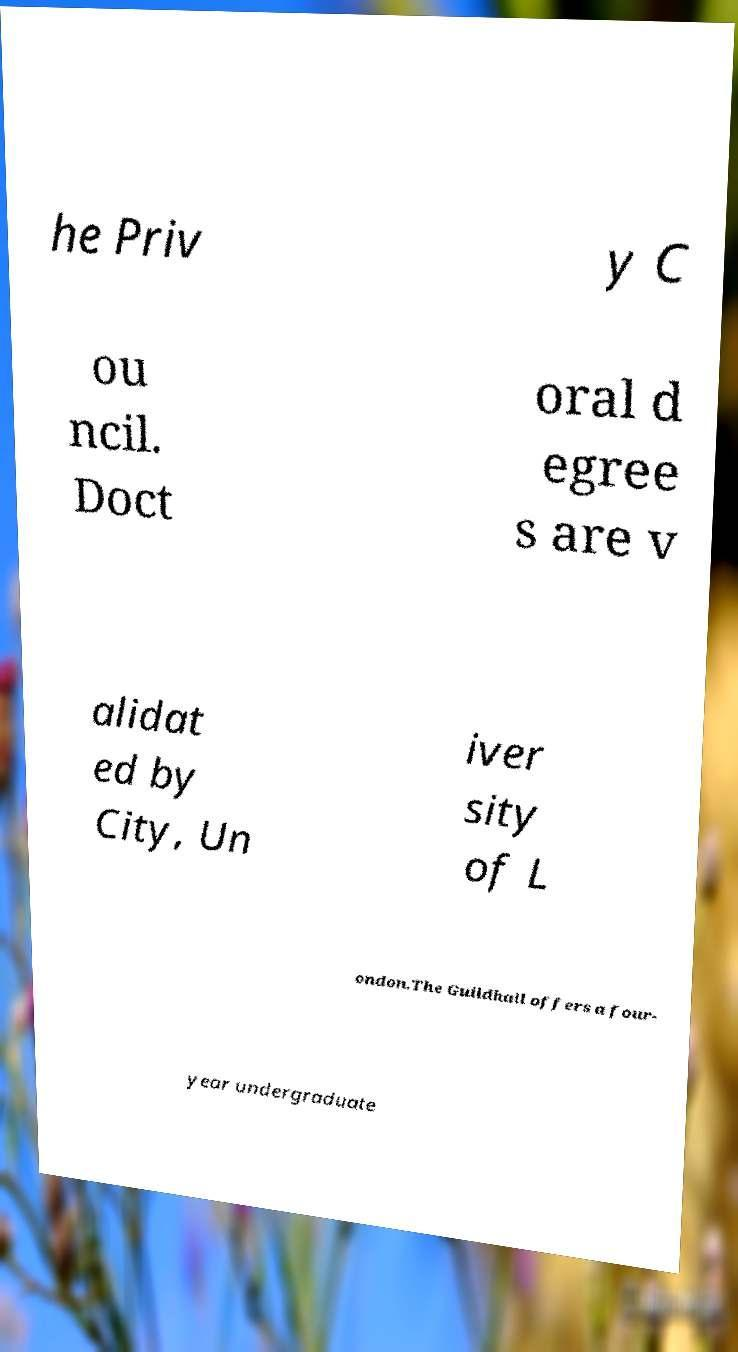Could you extract and type out the text from this image? he Priv y C ou ncil. Doct oral d egree s are v alidat ed by City, Un iver sity of L ondon.The Guildhall offers a four- year undergraduate 